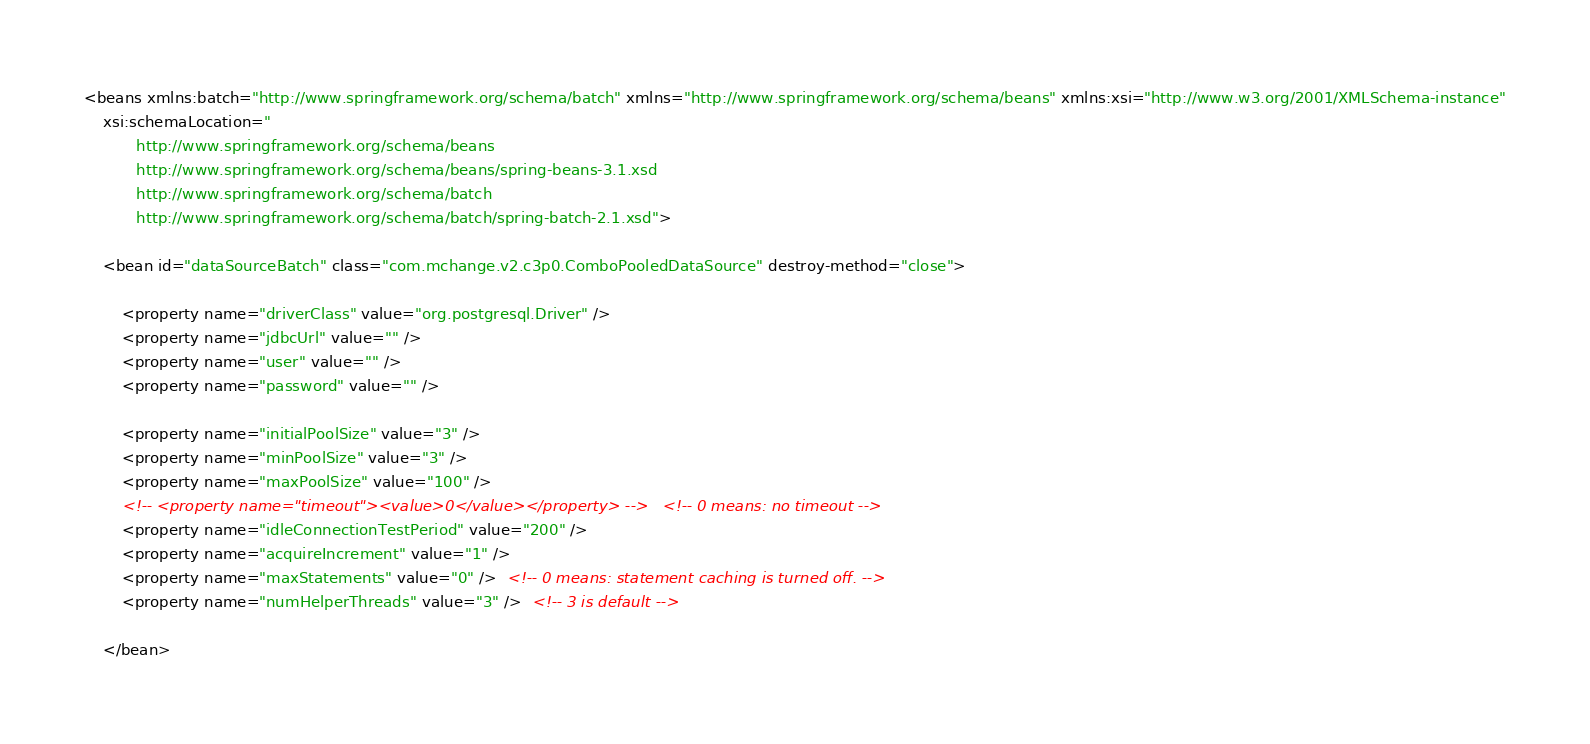<code> <loc_0><loc_0><loc_500><loc_500><_XML_><beans xmlns:batch="http://www.springframework.org/schema/batch" xmlns="http://www.springframework.org/schema/beans" xmlns:xsi="http://www.w3.org/2001/XMLSchema-instance"
    xsi:schemaLocation="
           http://www.springframework.org/schema/beans 
           http://www.springframework.org/schema/beans/spring-beans-3.1.xsd
           http://www.springframework.org/schema/batch 
           http://www.springframework.org/schema/batch/spring-batch-2.1.xsd">

    <bean id="dataSourceBatch" class="com.mchange.v2.c3p0.ComboPooledDataSource" destroy-method="close">

        <property name="driverClass" value="org.postgresql.Driver" />
        <property name="jdbcUrl" value="" />
        <property name="user" value="" />
        <property name="password" value="" />

        <property name="initialPoolSize" value="3" />
        <property name="minPoolSize" value="3" />
        <property name="maxPoolSize" value="100" />
        <!-- <property name="timeout"><value>0</value></property> -->   <!-- 0 means: no timeout -->
        <property name="idleConnectionTestPeriod" value="200" />
        <property name="acquireIncrement" value="1" />
        <property name="maxStatements" value="0" />  <!-- 0 means: statement caching is turned off. -->
        <property name="numHelperThreads" value="3" />  <!-- 3 is default -->

    </bean>
</code> 